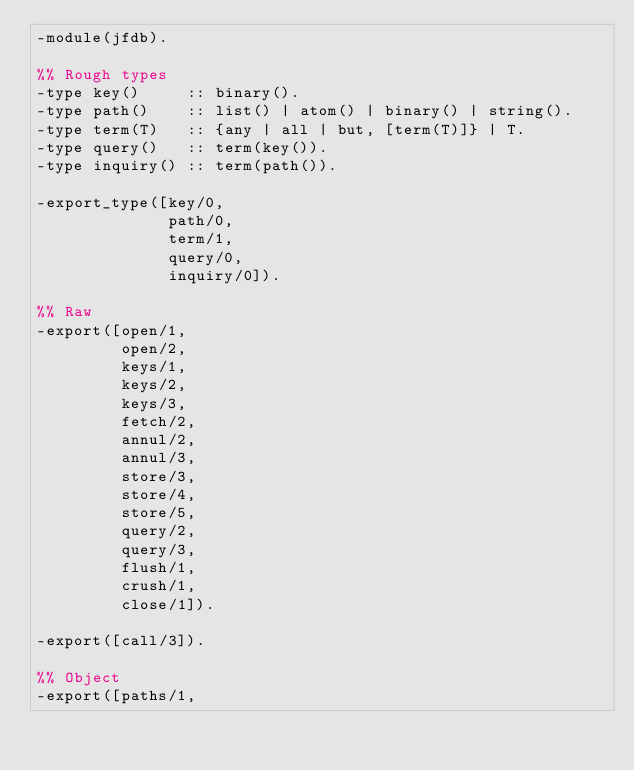Convert code to text. <code><loc_0><loc_0><loc_500><loc_500><_Erlang_>-module(jfdb).

%% Rough types
-type key()     :: binary().
-type path()    :: list() | atom() | binary() | string().
-type term(T)   :: {any | all | but, [term(T)]} | T.
-type query()   :: term(key()).
-type inquiry() :: term(path()).

-export_type([key/0,
              path/0,
              term/1,
              query/0,
              inquiry/0]).

%% Raw
-export([open/1,
         open/2,
         keys/1,
         keys/2,
         keys/3,
         fetch/2,
         annul/2,
         annul/3,
         store/3,
         store/4,
         store/5,
         query/2,
         query/3,
         flush/1,
         crush/1,
         close/1]).

-export([call/3]).

%% Object
-export([paths/1,</code> 